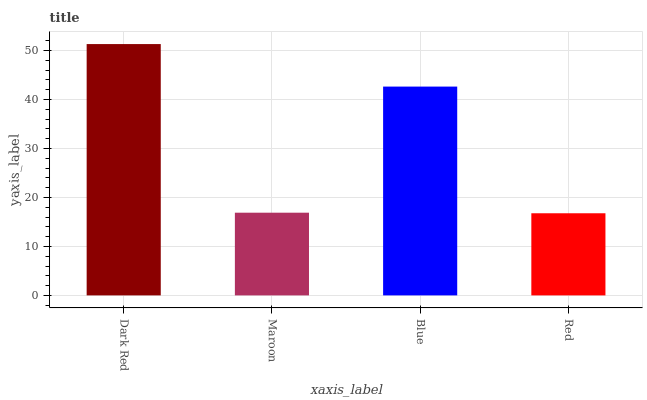Is Red the minimum?
Answer yes or no. Yes. Is Dark Red the maximum?
Answer yes or no. Yes. Is Maroon the minimum?
Answer yes or no. No. Is Maroon the maximum?
Answer yes or no. No. Is Dark Red greater than Maroon?
Answer yes or no. Yes. Is Maroon less than Dark Red?
Answer yes or no. Yes. Is Maroon greater than Dark Red?
Answer yes or no. No. Is Dark Red less than Maroon?
Answer yes or no. No. Is Blue the high median?
Answer yes or no. Yes. Is Maroon the low median?
Answer yes or no. Yes. Is Red the high median?
Answer yes or no. No. Is Dark Red the low median?
Answer yes or no. No. 